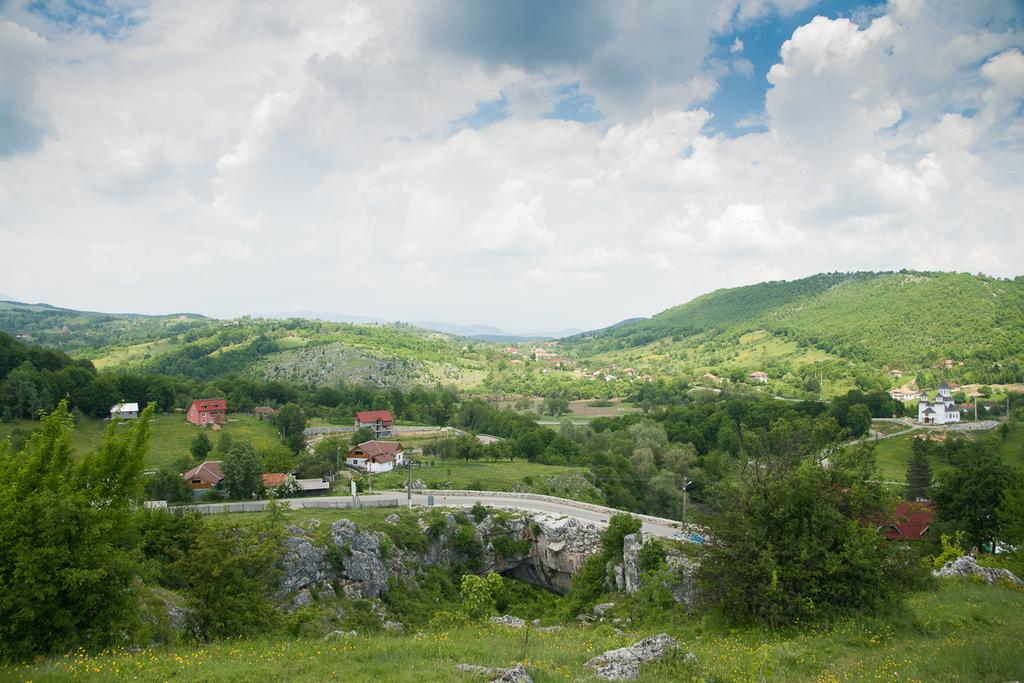What type of surface is visible in the image? There is grass on the surface in the image. What other natural elements can be seen in the image? There are trees in the image. What type of structures are present in the image? There are houses in the image. What is visible in the sky at the top of the image? There are clouds in the sky at the top of the image. Where is the kitten playing with a piece of wax in the image? There is no kitten or wax present in the image. What type of bird is sitting on the turkey in the image? There is no turkey or bird present in the image. 